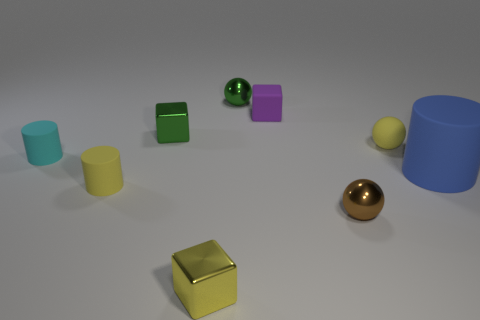Subtract all rubber blocks. How many blocks are left? 2 Add 1 tiny cyan matte cylinders. How many objects exist? 10 Subtract 1 cubes. How many cubes are left? 2 Subtract all balls. How many objects are left? 6 Add 9 small purple rubber things. How many small purple rubber things are left? 10 Add 2 cylinders. How many cylinders exist? 5 Subtract 1 yellow cylinders. How many objects are left? 8 Subtract all tiny cylinders. Subtract all large cylinders. How many objects are left? 6 